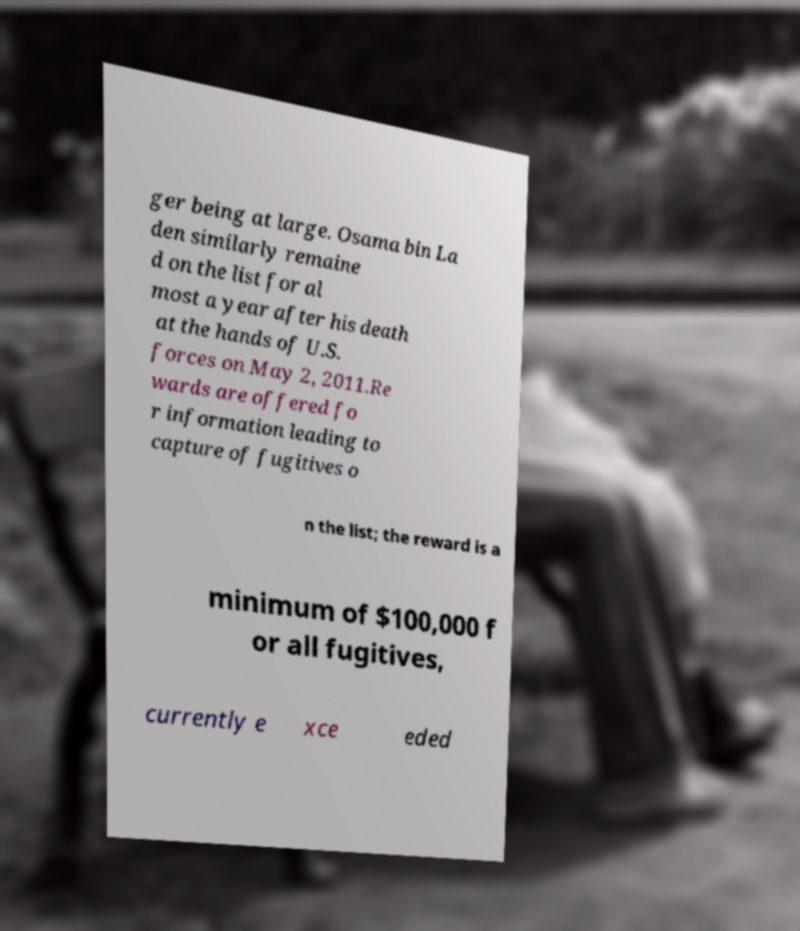Please identify and transcribe the text found in this image. ger being at large. Osama bin La den similarly remaine d on the list for al most a year after his death at the hands of U.S. forces on May 2, 2011.Re wards are offered fo r information leading to capture of fugitives o n the list; the reward is a minimum of $100,000 f or all fugitives, currently e xce eded 